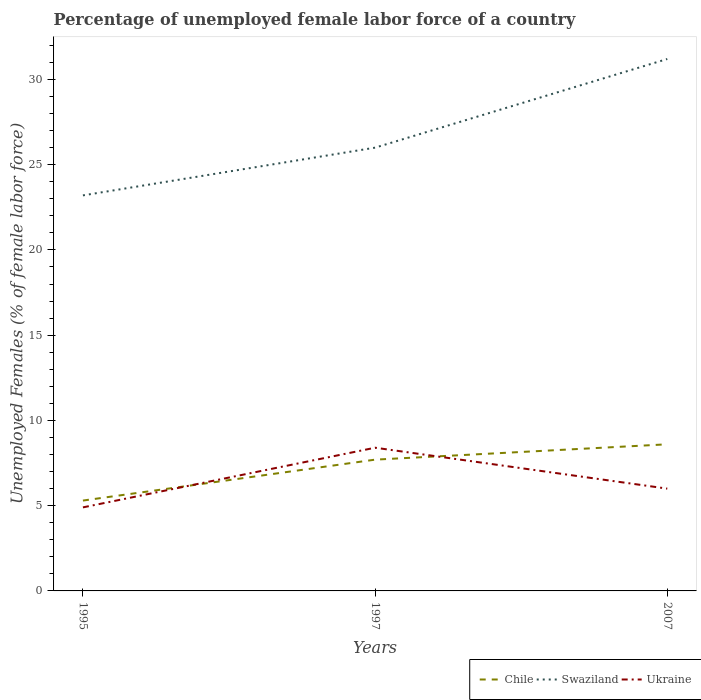Is the number of lines equal to the number of legend labels?
Provide a short and direct response. Yes. Across all years, what is the maximum percentage of unemployed female labor force in Swaziland?
Ensure brevity in your answer.  23.2. In which year was the percentage of unemployed female labor force in Swaziland maximum?
Ensure brevity in your answer.  1995. Is the percentage of unemployed female labor force in Swaziland strictly greater than the percentage of unemployed female labor force in Ukraine over the years?
Give a very brief answer. No. How many lines are there?
Your response must be concise. 3. How many years are there in the graph?
Keep it short and to the point. 3. Does the graph contain any zero values?
Keep it short and to the point. No. Where does the legend appear in the graph?
Your answer should be compact. Bottom right. How are the legend labels stacked?
Keep it short and to the point. Horizontal. What is the title of the graph?
Provide a short and direct response. Percentage of unemployed female labor force of a country. What is the label or title of the Y-axis?
Provide a short and direct response. Unemployed Females (% of female labor force). What is the Unemployed Females (% of female labor force) in Chile in 1995?
Your response must be concise. 5.3. What is the Unemployed Females (% of female labor force) of Swaziland in 1995?
Your answer should be compact. 23.2. What is the Unemployed Females (% of female labor force) of Ukraine in 1995?
Make the answer very short. 4.9. What is the Unemployed Females (% of female labor force) in Chile in 1997?
Offer a terse response. 7.7. What is the Unemployed Females (% of female labor force) in Swaziland in 1997?
Make the answer very short. 26. What is the Unemployed Females (% of female labor force) of Ukraine in 1997?
Provide a short and direct response. 8.4. What is the Unemployed Females (% of female labor force) in Chile in 2007?
Make the answer very short. 8.6. What is the Unemployed Females (% of female labor force) of Swaziland in 2007?
Keep it short and to the point. 31.2. What is the Unemployed Females (% of female labor force) in Ukraine in 2007?
Offer a very short reply. 6. Across all years, what is the maximum Unemployed Females (% of female labor force) of Chile?
Make the answer very short. 8.6. Across all years, what is the maximum Unemployed Females (% of female labor force) of Swaziland?
Provide a short and direct response. 31.2. Across all years, what is the maximum Unemployed Females (% of female labor force) of Ukraine?
Give a very brief answer. 8.4. Across all years, what is the minimum Unemployed Females (% of female labor force) in Chile?
Give a very brief answer. 5.3. Across all years, what is the minimum Unemployed Females (% of female labor force) of Swaziland?
Offer a very short reply. 23.2. Across all years, what is the minimum Unemployed Females (% of female labor force) in Ukraine?
Ensure brevity in your answer.  4.9. What is the total Unemployed Females (% of female labor force) in Chile in the graph?
Provide a succinct answer. 21.6. What is the total Unemployed Females (% of female labor force) of Swaziland in the graph?
Provide a short and direct response. 80.4. What is the total Unemployed Females (% of female labor force) of Ukraine in the graph?
Offer a terse response. 19.3. What is the difference between the Unemployed Females (% of female labor force) of Swaziland in 1995 and that in 1997?
Provide a short and direct response. -2.8. What is the difference between the Unemployed Females (% of female labor force) in Ukraine in 1995 and that in 2007?
Offer a terse response. -1.1. What is the difference between the Unemployed Females (% of female labor force) of Swaziland in 1997 and that in 2007?
Your answer should be compact. -5.2. What is the difference between the Unemployed Females (% of female labor force) of Chile in 1995 and the Unemployed Females (% of female labor force) of Swaziland in 1997?
Your answer should be very brief. -20.7. What is the difference between the Unemployed Females (% of female labor force) of Chile in 1995 and the Unemployed Females (% of female labor force) of Swaziland in 2007?
Offer a terse response. -25.9. What is the difference between the Unemployed Females (% of female labor force) of Chile in 1995 and the Unemployed Females (% of female labor force) of Ukraine in 2007?
Make the answer very short. -0.7. What is the difference between the Unemployed Females (% of female labor force) of Chile in 1997 and the Unemployed Females (% of female labor force) of Swaziland in 2007?
Offer a very short reply. -23.5. What is the average Unemployed Females (% of female labor force) in Swaziland per year?
Provide a succinct answer. 26.8. What is the average Unemployed Females (% of female labor force) in Ukraine per year?
Your response must be concise. 6.43. In the year 1995, what is the difference between the Unemployed Females (% of female labor force) in Chile and Unemployed Females (% of female labor force) in Swaziland?
Your answer should be very brief. -17.9. In the year 1995, what is the difference between the Unemployed Females (% of female labor force) of Chile and Unemployed Females (% of female labor force) of Ukraine?
Provide a short and direct response. 0.4. In the year 1995, what is the difference between the Unemployed Females (% of female labor force) in Swaziland and Unemployed Females (% of female labor force) in Ukraine?
Offer a terse response. 18.3. In the year 1997, what is the difference between the Unemployed Females (% of female labor force) in Chile and Unemployed Females (% of female labor force) in Swaziland?
Provide a succinct answer. -18.3. In the year 2007, what is the difference between the Unemployed Females (% of female labor force) in Chile and Unemployed Females (% of female labor force) in Swaziland?
Provide a succinct answer. -22.6. In the year 2007, what is the difference between the Unemployed Females (% of female labor force) of Swaziland and Unemployed Females (% of female labor force) of Ukraine?
Make the answer very short. 25.2. What is the ratio of the Unemployed Females (% of female labor force) in Chile in 1995 to that in 1997?
Your answer should be compact. 0.69. What is the ratio of the Unemployed Females (% of female labor force) of Swaziland in 1995 to that in 1997?
Your response must be concise. 0.89. What is the ratio of the Unemployed Females (% of female labor force) of Ukraine in 1995 to that in 1997?
Ensure brevity in your answer.  0.58. What is the ratio of the Unemployed Females (% of female labor force) in Chile in 1995 to that in 2007?
Your response must be concise. 0.62. What is the ratio of the Unemployed Females (% of female labor force) in Swaziland in 1995 to that in 2007?
Your response must be concise. 0.74. What is the ratio of the Unemployed Females (% of female labor force) of Ukraine in 1995 to that in 2007?
Offer a terse response. 0.82. What is the ratio of the Unemployed Females (% of female labor force) in Chile in 1997 to that in 2007?
Provide a succinct answer. 0.9. What is the difference between the highest and the second highest Unemployed Females (% of female labor force) in Ukraine?
Offer a terse response. 2.4. What is the difference between the highest and the lowest Unemployed Females (% of female labor force) in Swaziland?
Your answer should be very brief. 8. What is the difference between the highest and the lowest Unemployed Females (% of female labor force) of Ukraine?
Provide a short and direct response. 3.5. 